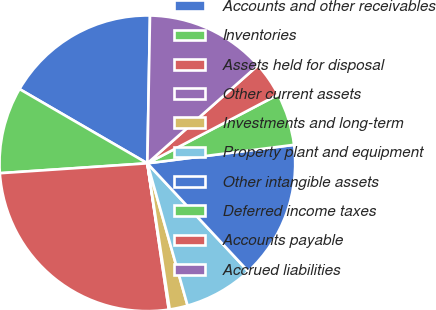<chart> <loc_0><loc_0><loc_500><loc_500><pie_chart><fcel>Accounts and other receivables<fcel>Inventories<fcel>Assets held for disposal<fcel>Other current assets<fcel>Investments and long-term<fcel>Property plant and equipment<fcel>Other intangible assets<fcel>Deferred income taxes<fcel>Accounts payable<fcel>Accrued liabilities<nl><fcel>16.91%<fcel>9.44%<fcel>26.25%<fcel>0.1%<fcel>1.97%<fcel>7.57%<fcel>15.04%<fcel>5.7%<fcel>3.84%<fcel>13.18%<nl></chart> 